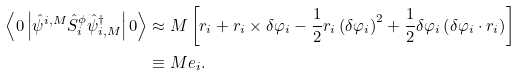<formula> <loc_0><loc_0><loc_500><loc_500>\left < 0 \left | \hat { \psi } ^ { i , M } \hat { S } _ { i } ^ { \phi } \hat { \psi } ^ { \dagger } _ { i , M } \right | 0 \right > & \approx M \left [ r _ { i } + r _ { i } \times \delta \varphi _ { i } - \frac { 1 } { 2 } r _ { i } \left ( \delta \varphi _ { i } \right ) ^ { 2 } + \frac { 1 } { 2 } \delta \varphi _ { i } \left ( \delta \varphi _ { i } \cdot r _ { i } \right ) \right ] \\ & \equiv M e _ { i } .</formula> 